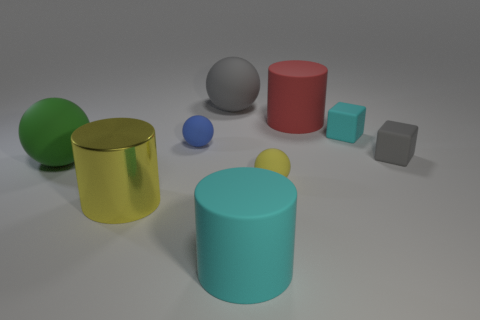Which objects in the image are closest to each other? The closest objects to each other are the small blue sphere and the gray cube, both of which are located on the right-hand side of the image. 